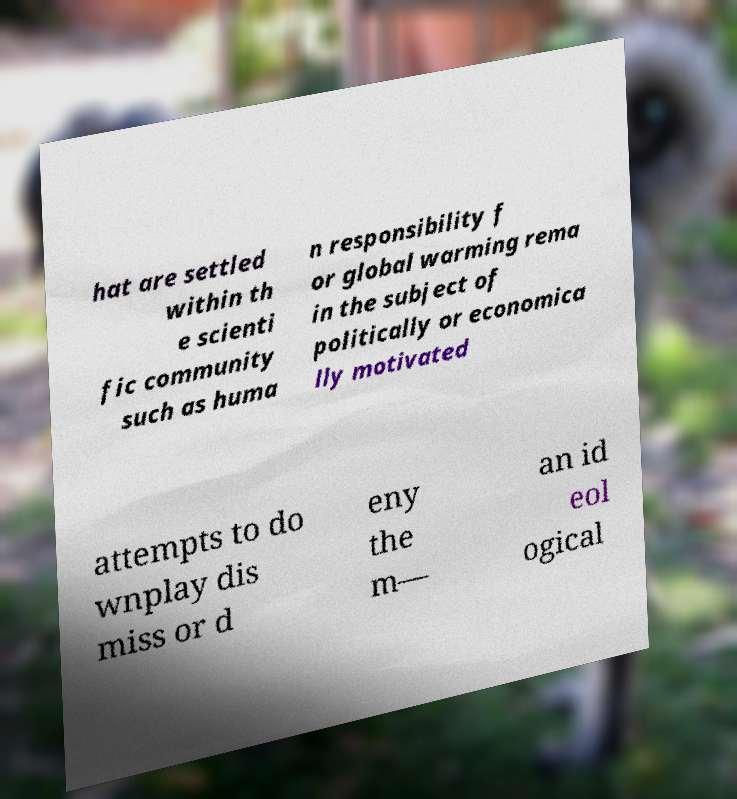Can you accurately transcribe the text from the provided image for me? hat are settled within th e scienti fic community such as huma n responsibility f or global warming rema in the subject of politically or economica lly motivated attempts to do wnplay dis miss or d eny the m— an id eol ogical 